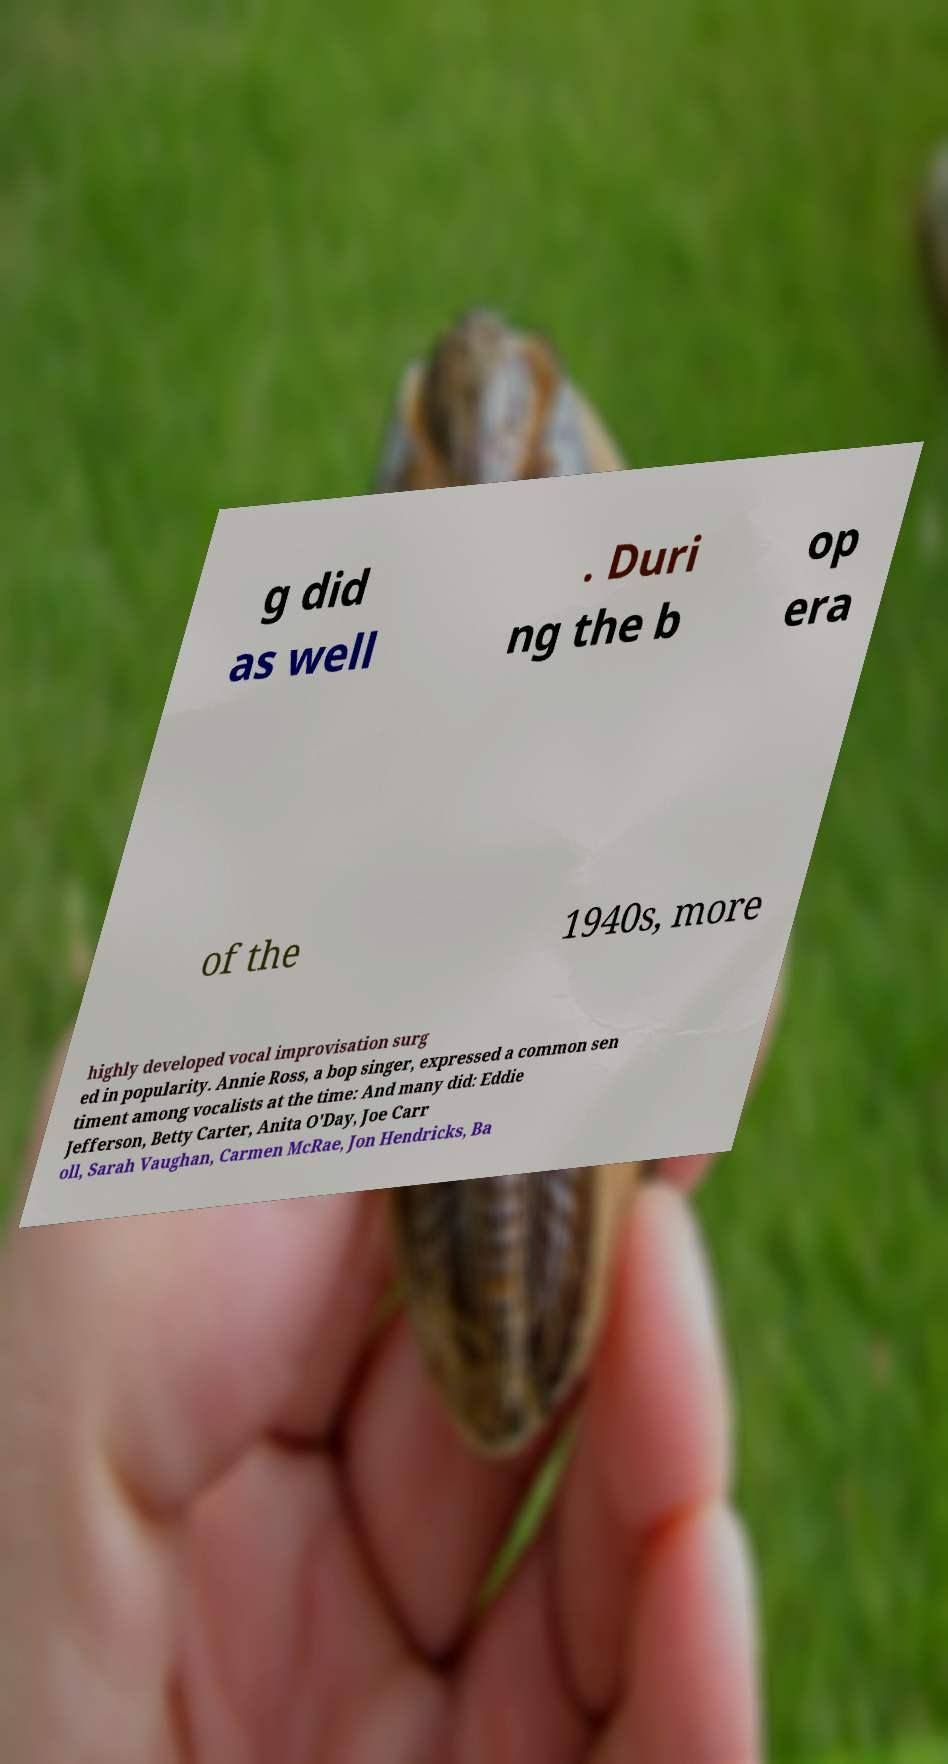Can you accurately transcribe the text from the provided image for me? g did as well . Duri ng the b op era of the 1940s, more highly developed vocal improvisation surg ed in popularity. Annie Ross, a bop singer, expressed a common sen timent among vocalists at the time: And many did: Eddie Jefferson, Betty Carter, Anita O'Day, Joe Carr oll, Sarah Vaughan, Carmen McRae, Jon Hendricks, Ba 